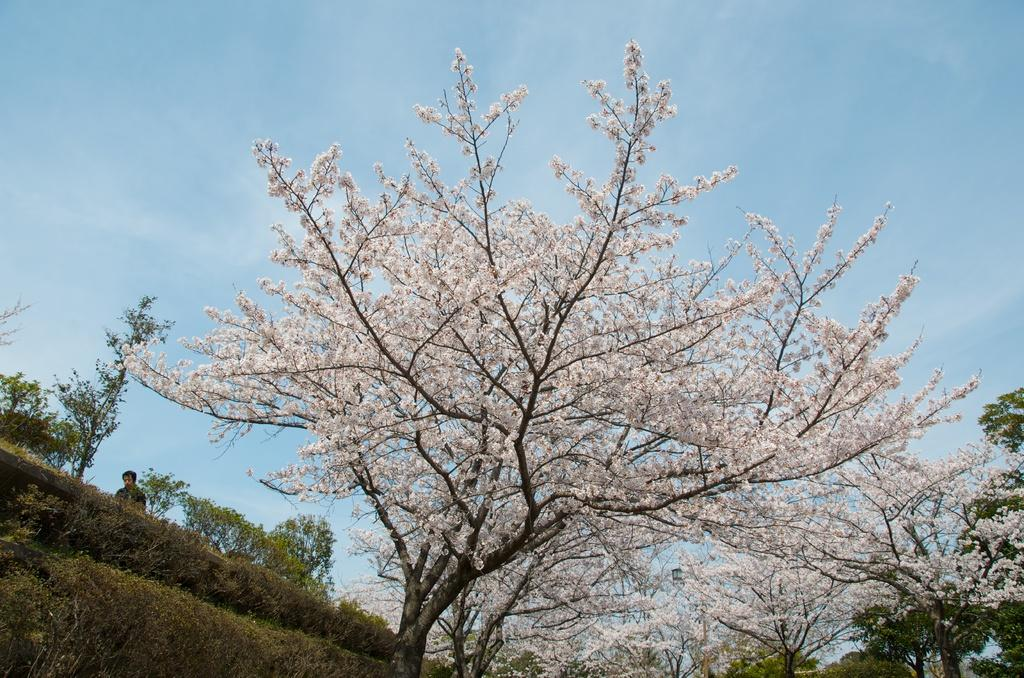What is present in the image? There is a person in the image. Can you describe the person's attire? The person is wearing clothes. What type of natural environment can be seen in the image? There is grass, a tree, and plants in the image. What is visible in the background of the image? The sky is visible in the image. How does the person plan to expand their knowledge while resting on the ground in the image? There is no indication in the image that the person is resting on the ground or planning to expand their knowledge. 